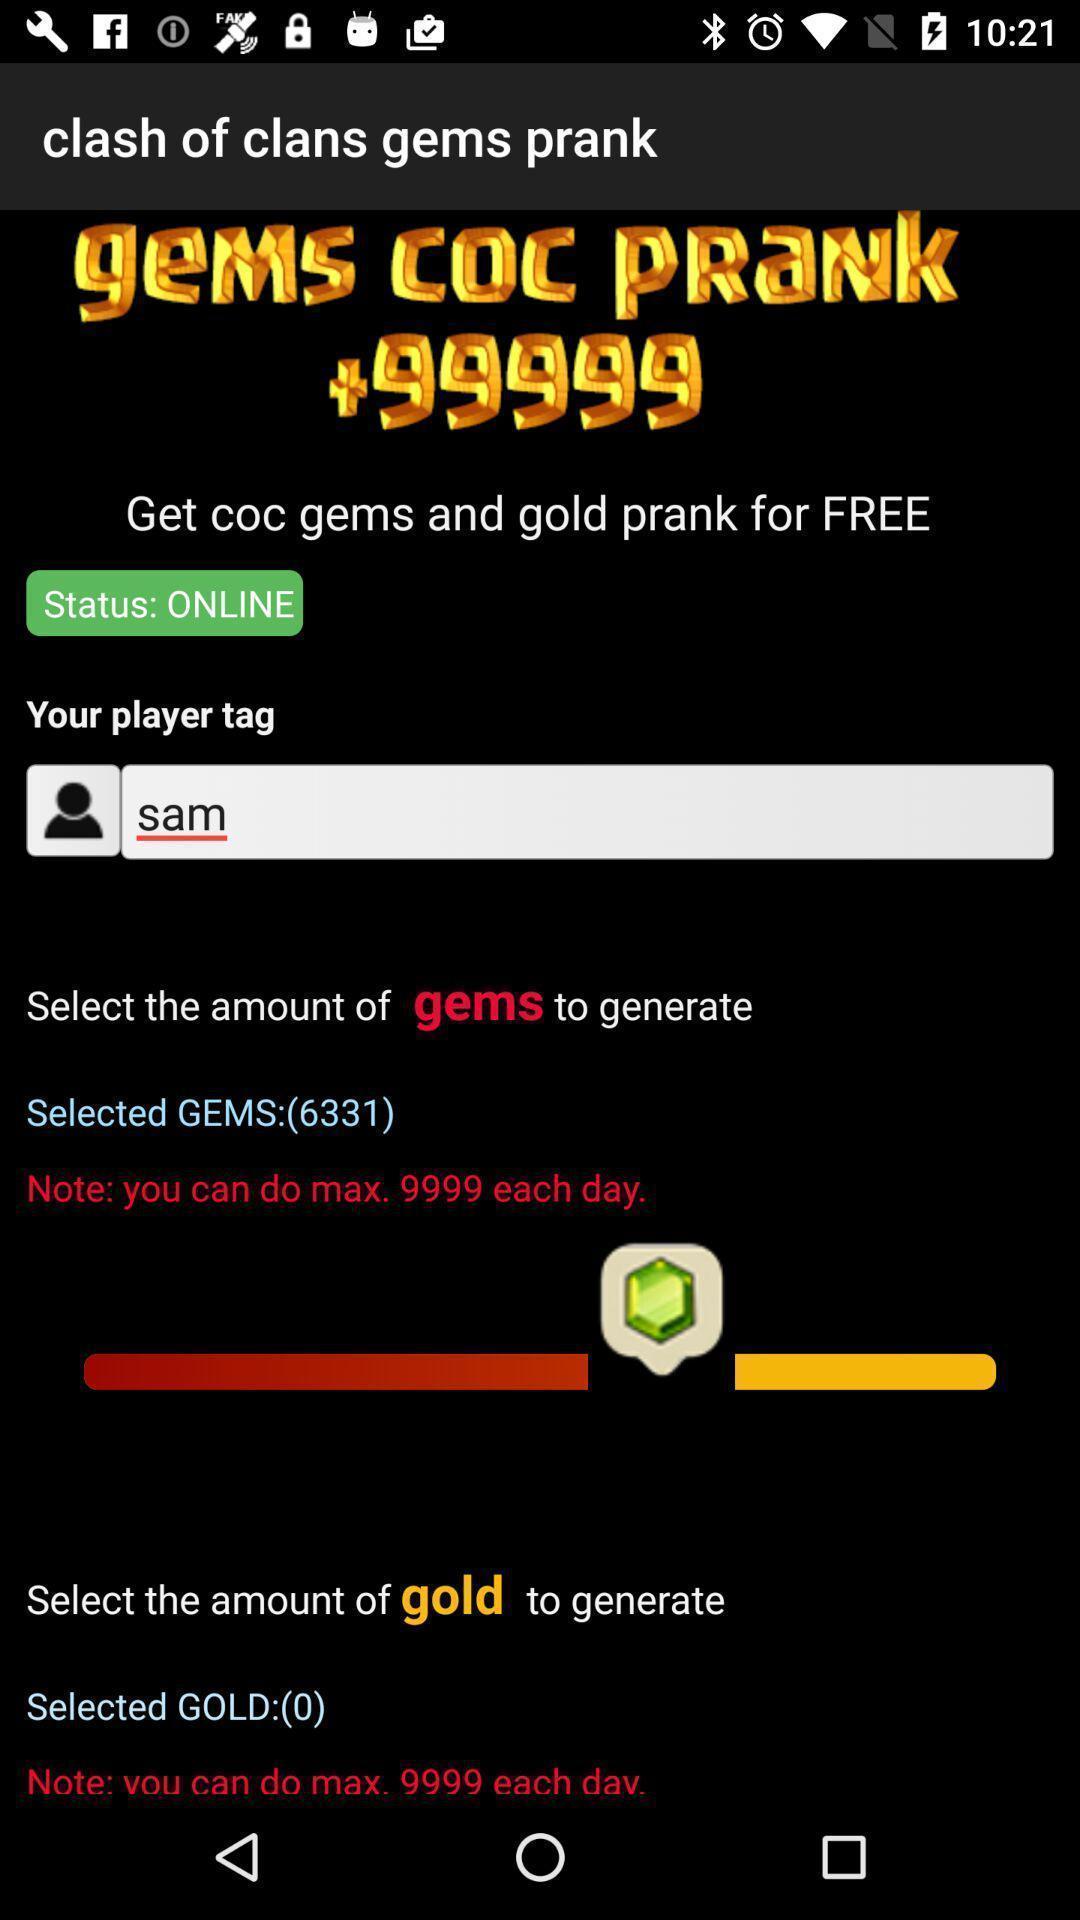Provide a description of this screenshot. Page displays multiple options. 